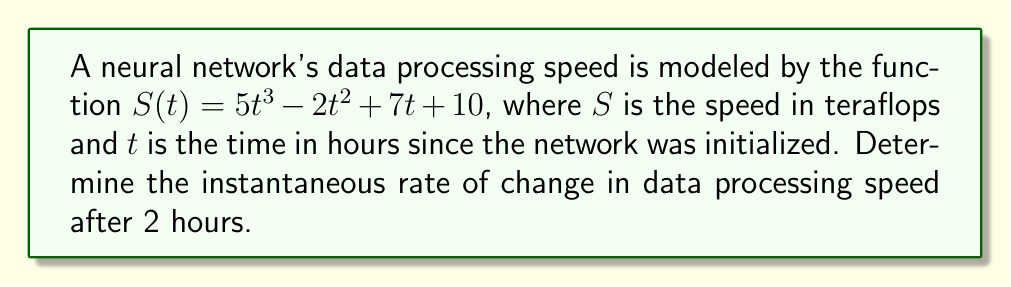Solve this math problem. To find the instantaneous rate of change, we need to calculate the derivative of the function $S(t)$ and evaluate it at $t=2$. Let's follow these steps:

1) First, let's find the derivative of $S(t)$:
   
   $S(t) = 5t^3 - 2t^2 + 7t + 10$
   
   $S'(t) = 15t^2 - 4t + 7$

2) Now, we need to evaluate $S'(t)$ at $t=2$:
   
   $S'(2) = 15(2)^2 - 4(2) + 7$
   
   $= 15(4) - 8 + 7$
   
   $= 60 - 8 + 7$
   
   $= 59$

3) Interpret the result:
   The instantaneous rate of change at $t=2$ is 59 teraflops per hour.

This means that after 2 hours, the data processing speed of the neural network is increasing at a rate of 59 teraflops per hour.
Answer: 59 teraflops/hour 